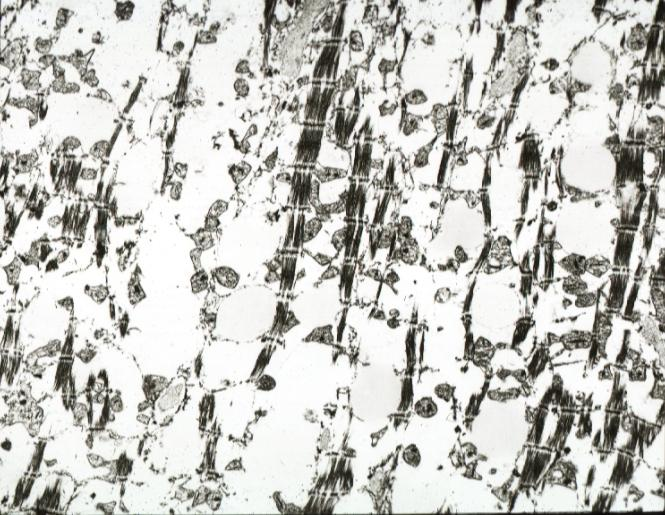where is this?
Answer the question using a single word or phrase. Heart 